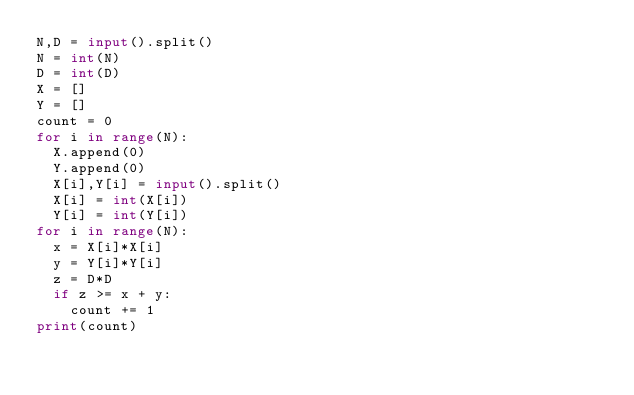Convert code to text. <code><loc_0><loc_0><loc_500><loc_500><_Python_>N,D = input().split()
N = int(N)
D = int(D)
X = []
Y = []
count = 0
for i in range(N):
  X.append(0)
  Y.append(0)
  X[i],Y[i] = input().split()
  X[i] = int(X[i])
  Y[i] = int(Y[i])
for i in range(N):
  x = X[i]*X[i]
  y = Y[i]*Y[i]
  z = D*D
  if z >= x + y:
    count += 1
print(count)</code> 